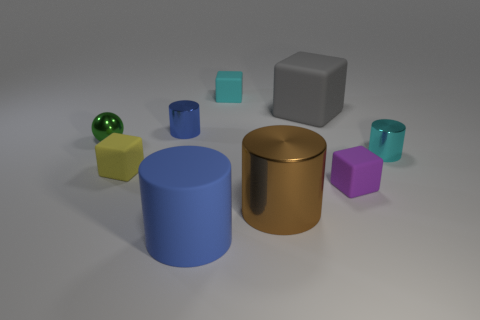Are there more big gray blocks than small red spheres?
Offer a terse response. Yes. How many other objects are there of the same shape as the yellow object?
Give a very brief answer. 3. There is a cylinder that is both behind the small purple matte object and to the left of the tiny cyan shiny cylinder; what is its material?
Make the answer very short. Metal. The yellow object has what size?
Your response must be concise. Small. What number of blocks are in front of the small cube that is behind the small cyan object that is in front of the small blue object?
Make the answer very short. 3. There is a metallic thing in front of the tiny metal object to the right of the purple matte object; what shape is it?
Provide a short and direct response. Cylinder. What size is the cyan rubber object that is the same shape as the tiny purple rubber object?
Your answer should be compact. Small. There is a tiny metal cylinder that is behind the cyan shiny thing; what color is it?
Keep it short and to the point. Blue. There is a cyan object that is behind the tiny cylinder on the right side of the cyan thing that is behind the small cyan cylinder; what is its material?
Keep it short and to the point. Rubber. How big is the cyan thing on the left side of the small cylinder in front of the green metallic sphere?
Keep it short and to the point. Small. 